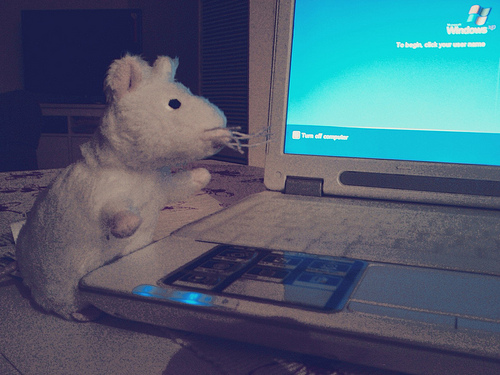<image>
Is there a toy rabbit to the right of the laptop? No. The toy rabbit is not to the right of the laptop. The horizontal positioning shows a different relationship. 